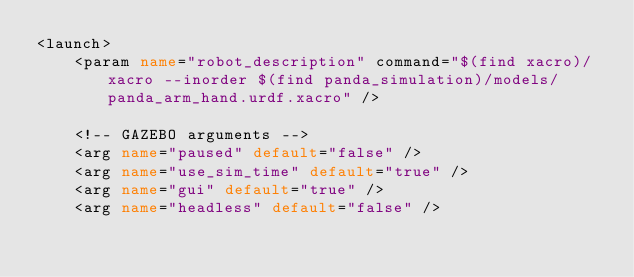<code> <loc_0><loc_0><loc_500><loc_500><_XML_><launch>
    <param name="robot_description" command="$(find xacro)/xacro --inorder $(find panda_simulation)/models/panda_arm_hand.urdf.xacro" />

    <!-- GAZEBO arguments -->
    <arg name="paused" default="false" />
    <arg name="use_sim_time" default="true" />
    <arg name="gui" default="true" />
    <arg name="headless" default="false" /></code> 